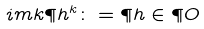<formula> <loc_0><loc_0><loc_500><loc_500>\L i m k \P h ^ { k } \colon = \P h \in \P O</formula> 